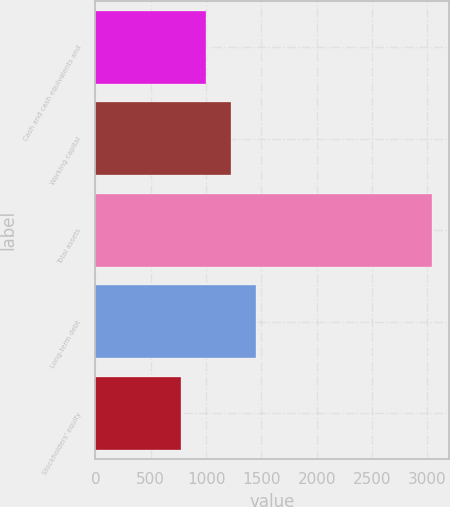Convert chart to OTSL. <chart><loc_0><loc_0><loc_500><loc_500><bar_chart><fcel>Cash and cash equivalents and<fcel>Working capital<fcel>Total assets<fcel>Long-term debt<fcel>Stockholders' equity<nl><fcel>996.2<fcel>1223.4<fcel>3041<fcel>1450.6<fcel>769<nl></chart> 